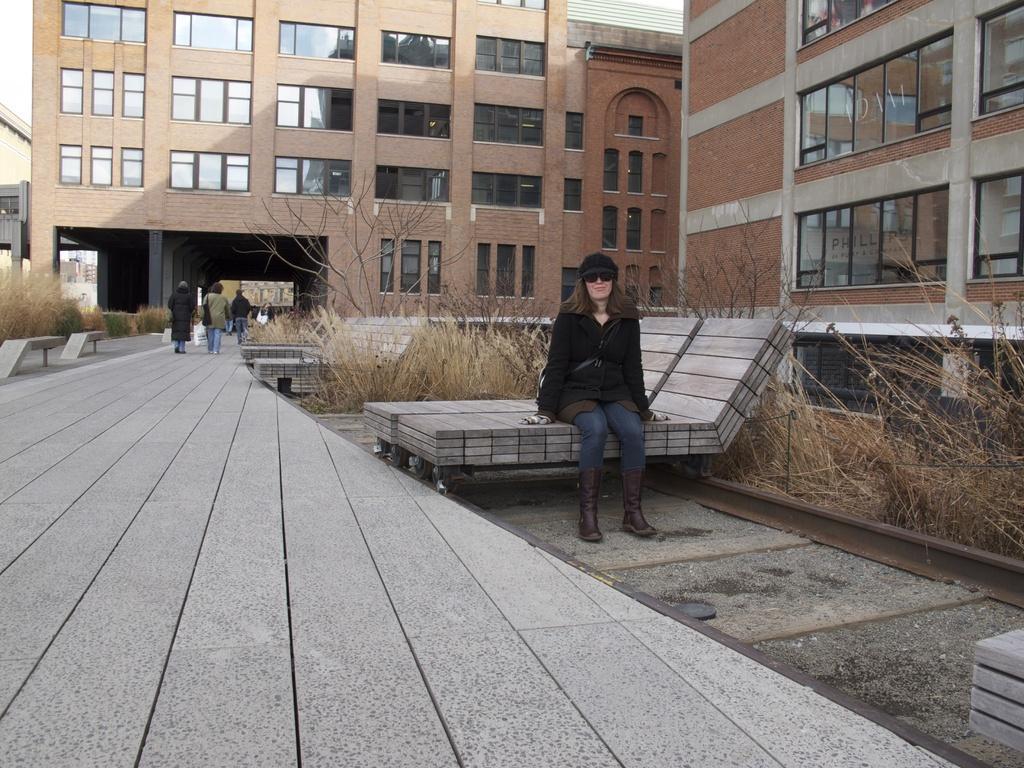Could you give a brief overview of what you see in this image? In this image i can see a woman sitting on the bench wearing a hat and glasses. In the background i can see the grass, a tree, a building, sky and few people walking. 